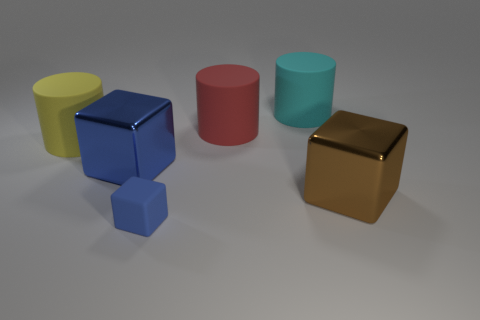Is there anything else that has the same size as the matte block?
Ensure brevity in your answer.  No. There is a brown cube that is the same size as the cyan matte thing; what is it made of?
Your answer should be compact. Metal. How many other objects are there of the same material as the large blue thing?
Offer a terse response. 1. Does the red matte cylinder have the same size as the metal object left of the red matte cylinder?
Your response must be concise. Yes. Are there fewer yellow cylinders that are in front of the large blue block than blue things that are left of the blue rubber object?
Provide a succinct answer. Yes. There is a cube behind the brown metallic object; what is its size?
Offer a terse response. Large. Does the red rubber cylinder have the same size as the blue rubber object?
Offer a very short reply. No. How many big objects are left of the cyan matte cylinder and in front of the large red cylinder?
Provide a short and direct response. 2. What number of brown things are either big balls or large metal blocks?
Provide a succinct answer. 1. How many metallic things are big cubes or red things?
Give a very brief answer. 2. 